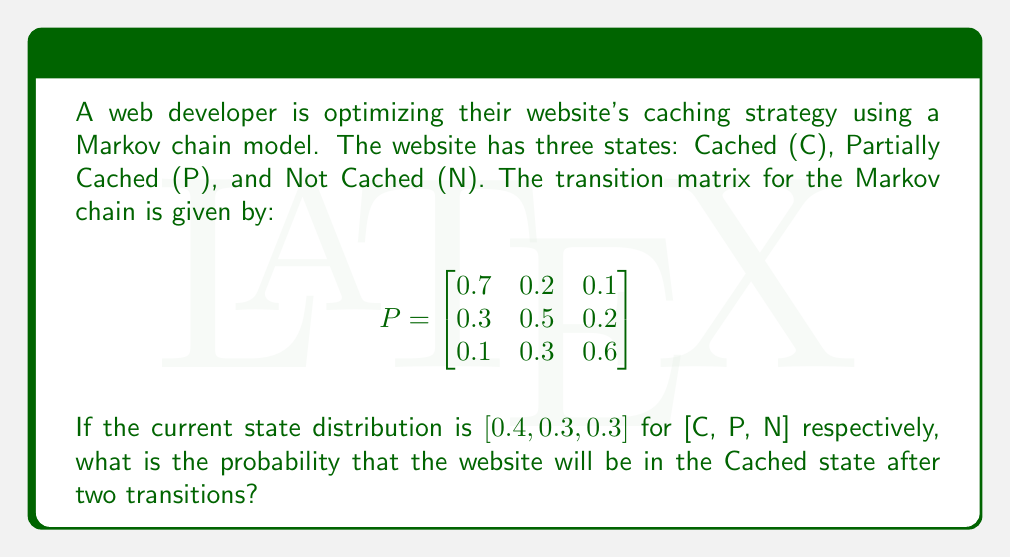Can you answer this question? To solve this problem, we need to use the properties of Markov chains and matrix multiplication. Let's break it down step-by-step:

1. We are given the initial state distribution:
   $\pi_0 = [0.4, 0.3, 0.3]$

2. We need to find the state distribution after two transitions. This can be calculated by multiplying the initial distribution by the transition matrix twice:
   $\pi_2 = \pi_0 \cdot P^2$

3. First, let's calculate $P^2$:
   $$
   P^2 = P \cdot P = \begin{bmatrix}
   0.7 & 0.2 & 0.1 \\
   0.3 & 0.5 & 0.2 \\
   0.1 & 0.3 & 0.6
   \end{bmatrix} \cdot \begin{bmatrix}
   0.7 & 0.2 & 0.1 \\
   0.3 & 0.5 & 0.2 \\
   0.1 & 0.3 & 0.6
   \end{bmatrix}
   $$

4. Performing the matrix multiplication:
   $$
   P^2 = \begin{bmatrix}
   0.56 & 0.27 & 0.17 \\
   0.37 & 0.41 & 0.22 \\
   0.22 & 0.37 & 0.41
   \end{bmatrix}
   $$

5. Now, we multiply the initial distribution by $P^2$:
   $\pi_2 = [0.4, 0.3, 0.3] \cdot \begin{bmatrix}
   0.56 & 0.27 & 0.17 \\
   0.37 & 0.41 & 0.22 \\
   0.22 & 0.37 & 0.41
   \end{bmatrix}$

6. Performing this multiplication:
   $\pi_2 = [0.4 \cdot 0.56 + 0.3 \cdot 0.37 + 0.3 \cdot 0.22, \ldots]$
   $\pi_2 = [0.224 + 0.111 + 0.066, \ldots]$
   $\pi_2 = [0.401, 0.343, 0.256]$

7. The probability of being in the Cached state after two transitions is the first element of $\pi_2$, which is 0.401 or 40.1%.
Answer: 0.401 